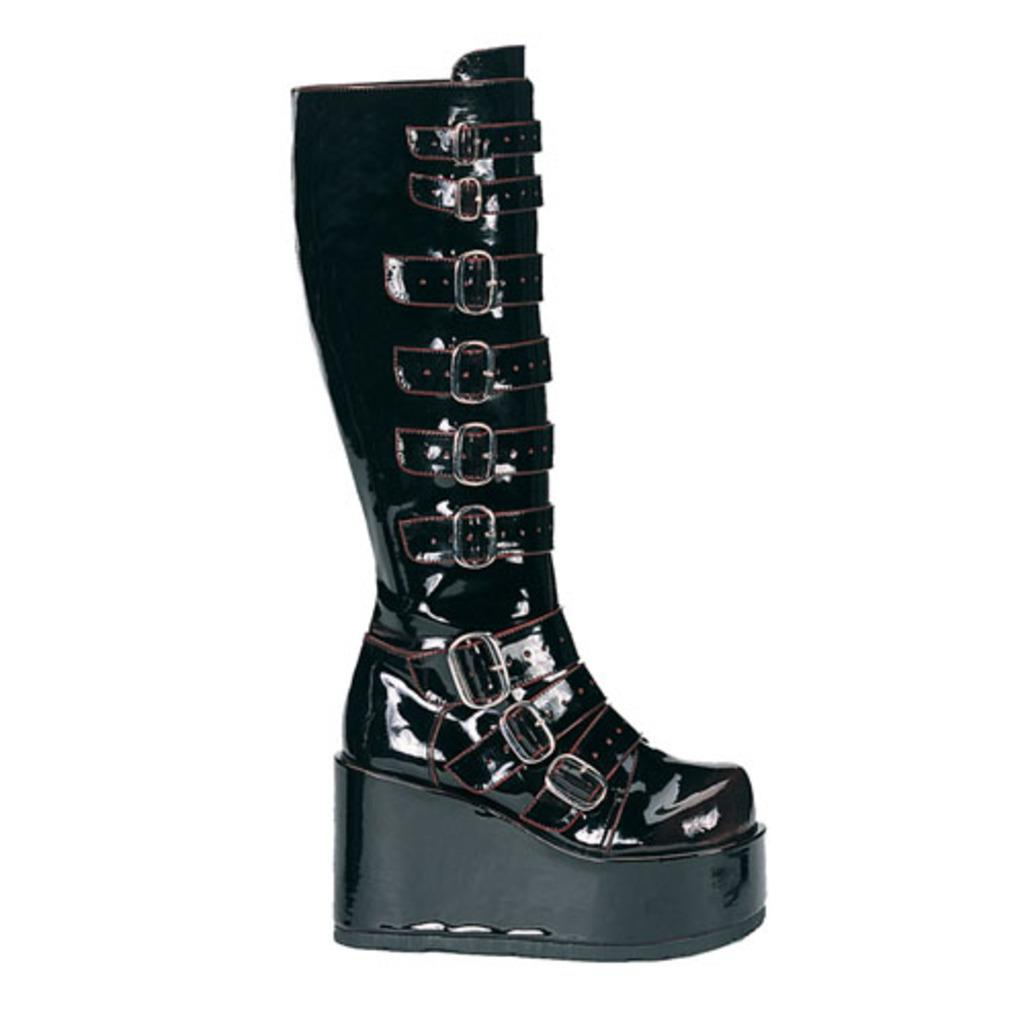What type of footwear is in the image? There is a black color boot in the image. What feature can be seen on the boot? The boot has buckles. What color is the background of the image? The background of the image is white. What is the girl's opinion about the stick in the image? There is no girl or stick present in the image, so it is not possible to determine her opinion. 